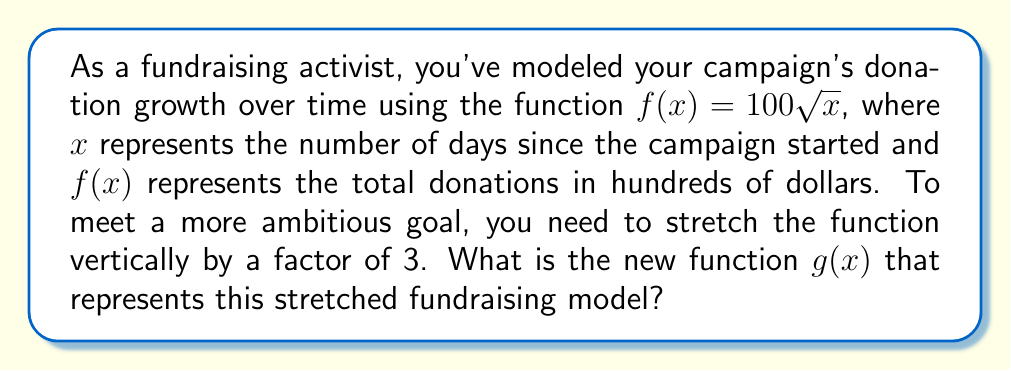What is the answer to this math problem? To vertically stretch a function by a factor of $k$, we multiply the entire function by $k$. In this case, $k = 3$.

Given:
- Original function: $f(x) = 100\sqrt{x}$
- Stretch factor: $k = 3$

Step 1: Multiply the original function by the stretch factor.
$g(x) = k \cdot f(x)$
$g(x) = 3 \cdot (100\sqrt{x})$

Step 2: Simplify the expression.
$g(x) = 300\sqrt{x}$

This new function $g(x) = 300\sqrt{x}$ represents the stretched fundraising model, where the growth rate and total donations are tripled compared to the original model.
Answer: $g(x) = 300\sqrt{x}$ 